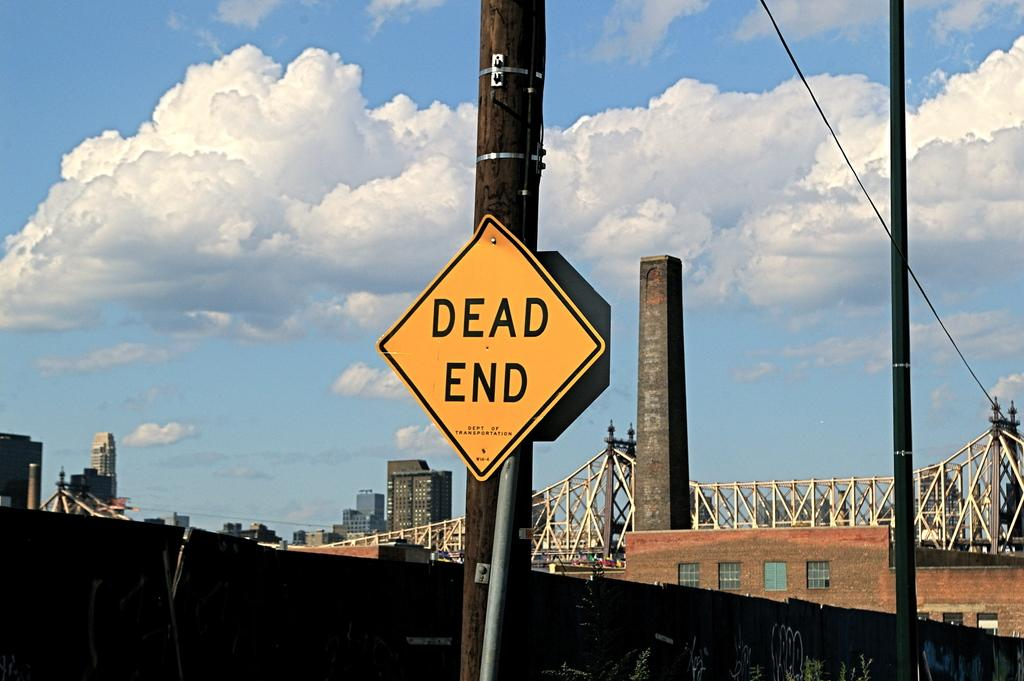<image>
Share a concise interpretation of the image provided. Yellow and black Dead End sign on a brown pole. 